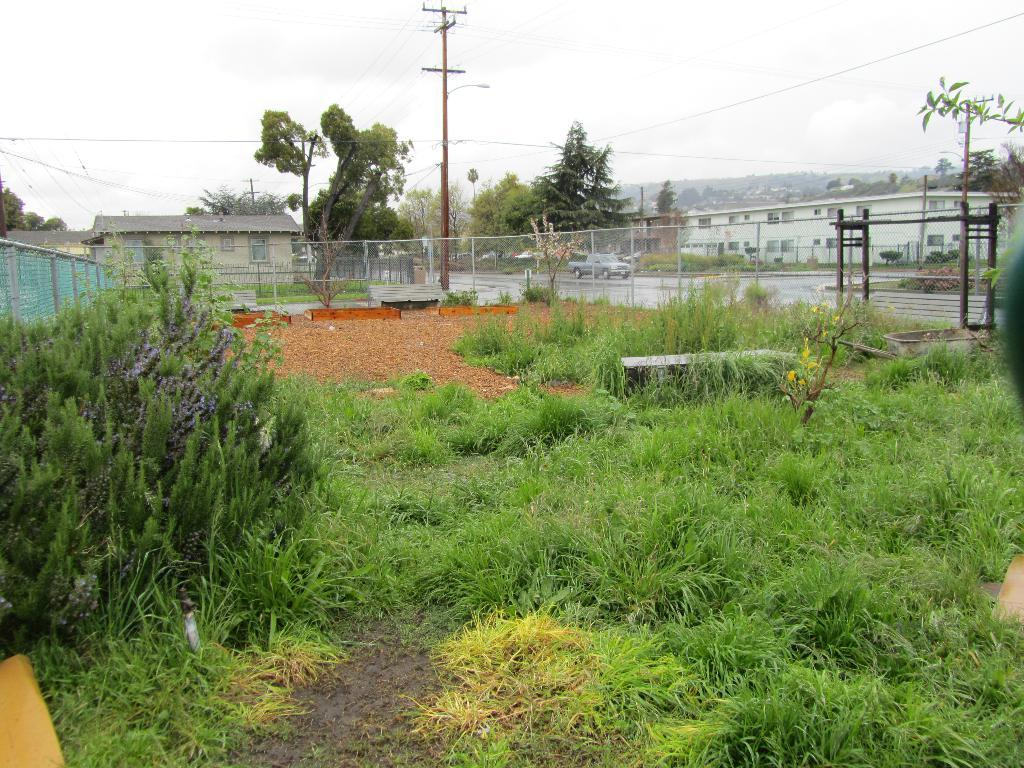What type of vegetation can be seen in the image? There are plants, grass, and trees in the image. What type of structure is present in the image? There is a house with a roof in the image. What is the condition of the sky in the image? The sky appears to be cloudy in the image. What other objects can be seen in the image? There is a fence, an utility pole with wires, and a pole in the image. What month is it in the image? The month cannot be determined from the image, as it does not contain any information about the time of year. What grade is the house in the image? The image does not provide any information about the grade or quality of the house. 